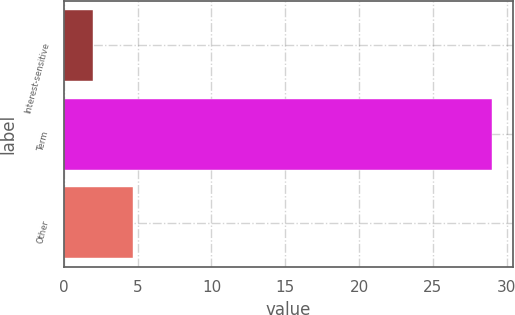Convert chart. <chart><loc_0><loc_0><loc_500><loc_500><bar_chart><fcel>Interest-sensitive<fcel>Term<fcel>Other<nl><fcel>2<fcel>29<fcel>4.7<nl></chart> 